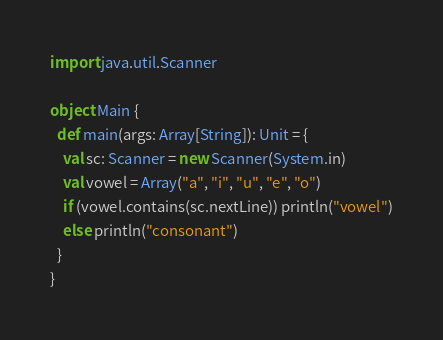Convert code to text. <code><loc_0><loc_0><loc_500><loc_500><_Scala_>import java.util.Scanner

object Main {
  def main(args: Array[String]): Unit = {
    val sc: Scanner = new Scanner(System.in)
    val vowel = Array("a", "i", "u", "e", "o")
    if (vowel.contains(sc.nextLine)) println("vowel")
    else println("consonant")
  }
}
</code> 